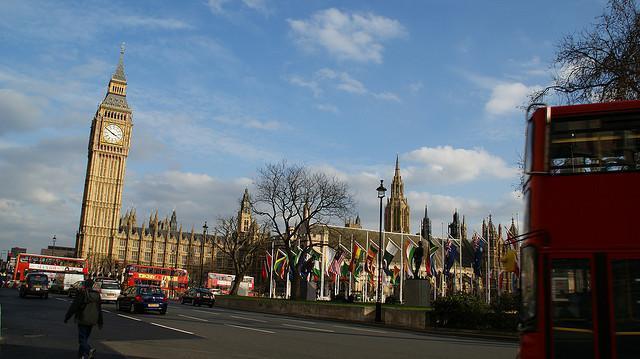Why are there so many buses?
Make your selection from the four choices given to correctly answer the question.
Options: Tourist destination, coincidence, break time, rush hour. Tourist destination. 